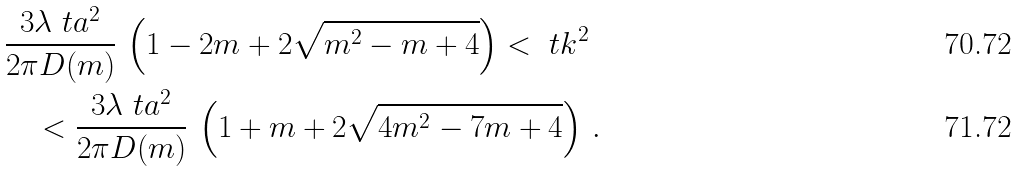Convert formula to latex. <formula><loc_0><loc_0><loc_500><loc_500>& \frac { 3 \lambda \ t a ^ { 2 } } { 2 \pi D ( m ) } \, \left ( 1 - 2 m + 2 \sqrt { m ^ { 2 } - m + 4 } \right ) < \ t k ^ { 2 } \\ & \quad < \frac { 3 \lambda \ t a ^ { 2 } } { 2 \pi D ( m ) } \, \left ( 1 + m + 2 \sqrt { 4 m ^ { 2 } - 7 m + 4 } \right ) \, .</formula> 